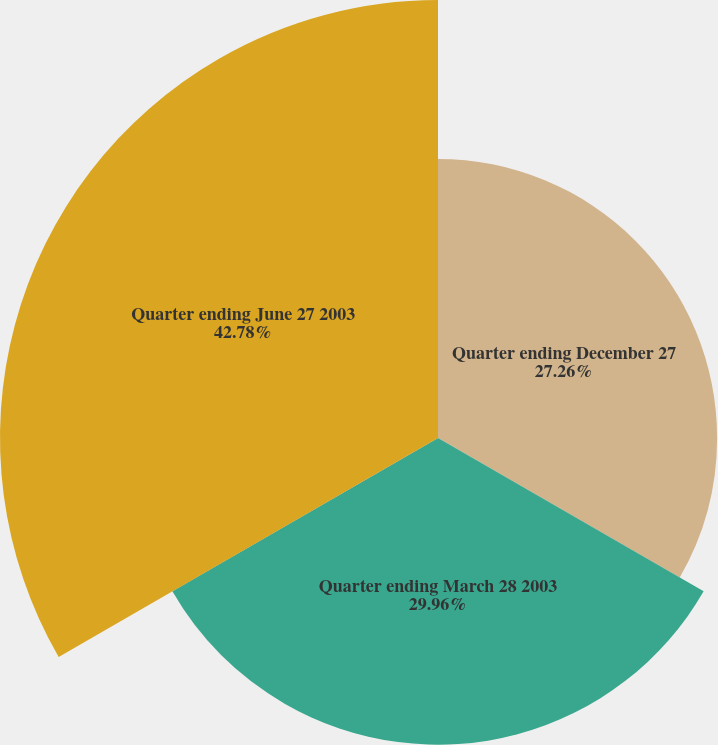Convert chart. <chart><loc_0><loc_0><loc_500><loc_500><pie_chart><fcel>Quarter ending December 27<fcel>Quarter ending March 28 2003<fcel>Quarter ending June 27 2003<nl><fcel>27.26%<fcel>29.96%<fcel>42.78%<nl></chart> 